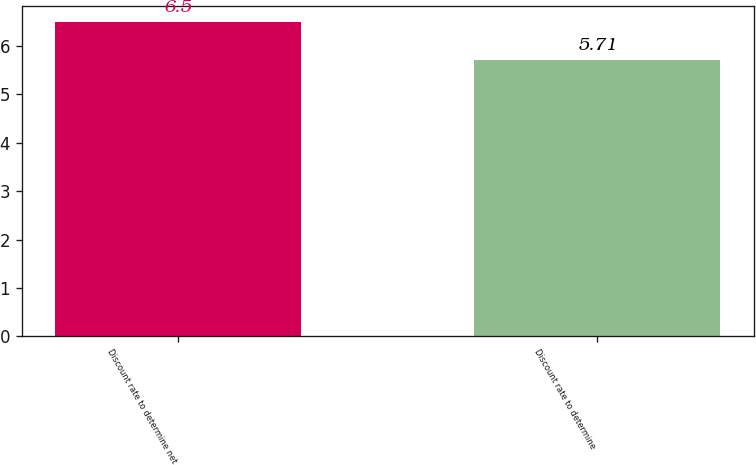Convert chart. <chart><loc_0><loc_0><loc_500><loc_500><bar_chart><fcel>Discount rate to determine net<fcel>Discount rate to determine<nl><fcel>6.5<fcel>5.71<nl></chart> 